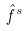Convert formula to latex. <formula><loc_0><loc_0><loc_500><loc_500>\hat { f } ^ { s }</formula> 